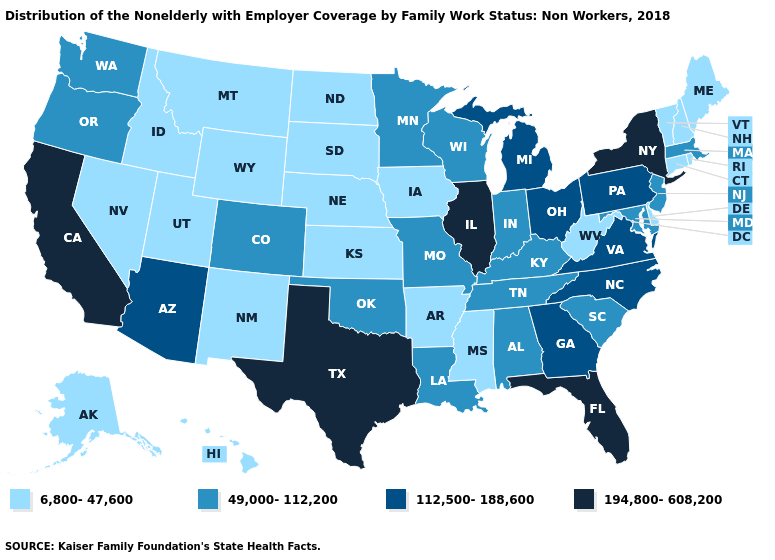What is the value of Wisconsin?
Give a very brief answer. 49,000-112,200. What is the value of Mississippi?
Keep it brief. 6,800-47,600. Does Wisconsin have a lower value than Illinois?
Quick response, please. Yes. Does New Mexico have the lowest value in the USA?
Short answer required. Yes. Does the first symbol in the legend represent the smallest category?
Answer briefly. Yes. What is the lowest value in the USA?
Keep it brief. 6,800-47,600. What is the value of Maryland?
Answer briefly. 49,000-112,200. Name the states that have a value in the range 194,800-608,200?
Write a very short answer. California, Florida, Illinois, New York, Texas. What is the highest value in the USA?
Answer briefly. 194,800-608,200. Does Tennessee have a higher value than Rhode Island?
Quick response, please. Yes. What is the value of South Carolina?
Answer briefly. 49,000-112,200. Among the states that border Vermont , does New Hampshire have the lowest value?
Give a very brief answer. Yes. What is the lowest value in states that border Washington?
Quick response, please. 6,800-47,600. Does Minnesota have a higher value than Rhode Island?
Be succinct. Yes. What is the value of Maine?
Write a very short answer. 6,800-47,600. 